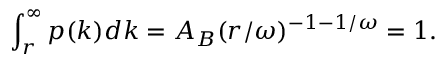<formula> <loc_0><loc_0><loc_500><loc_500>\int _ { r } ^ { \infty } p ( k ) d k = A _ { B } ( r / \omega ) ^ { - 1 - 1 / \omega } = 1 .</formula> 